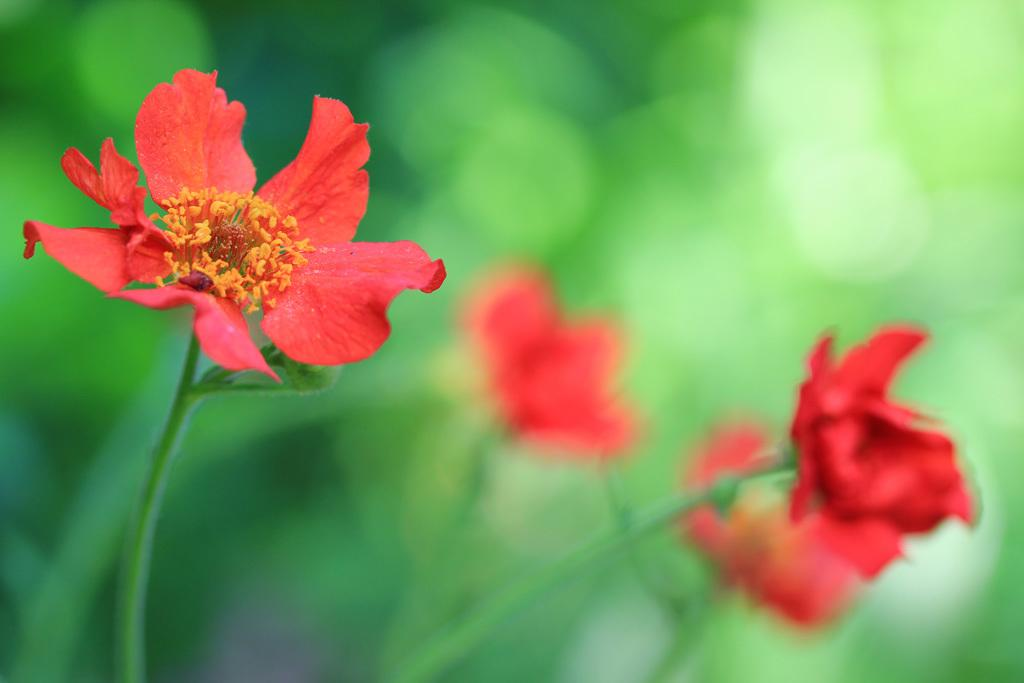What type of plants are visible in the image? There are flower plants in the image. What color are the flowers on the plants? The flowers are red in color. Can you describe the background of the image? The background of the image is blurred. What type of account is being discussed in the image? There is no account being discussed in the image; it features flower plants with red flowers and a blurred background. 